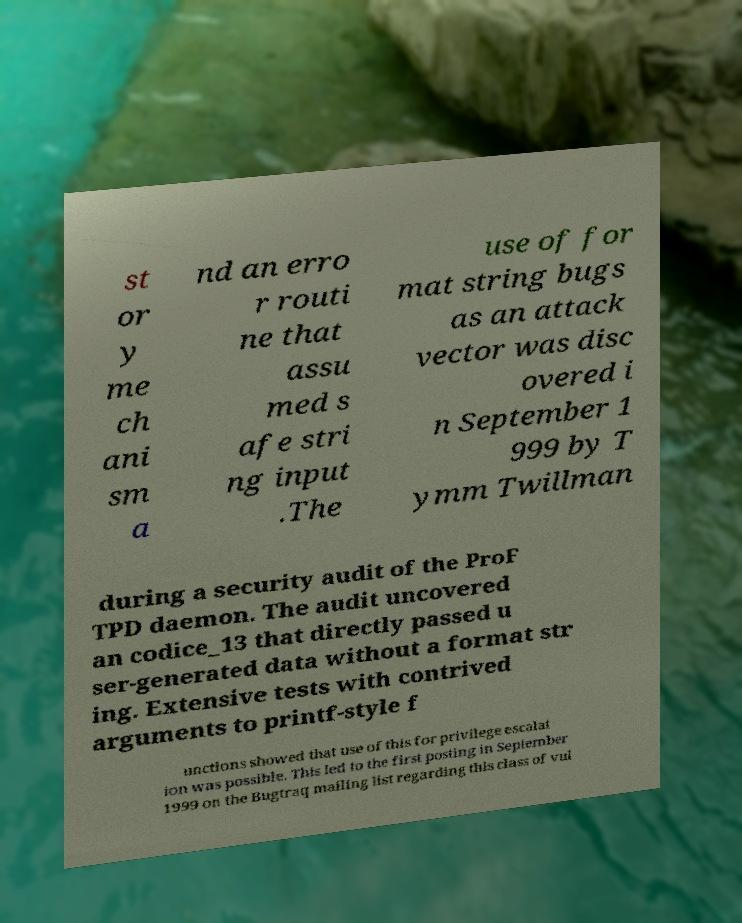Please identify and transcribe the text found in this image. st or y me ch ani sm a nd an erro r routi ne that assu med s afe stri ng input .The use of for mat string bugs as an attack vector was disc overed i n September 1 999 by T ymm Twillman during a security audit of the ProF TPD daemon. The audit uncovered an codice_13 that directly passed u ser-generated data without a format str ing. Extensive tests with contrived arguments to printf-style f unctions showed that use of this for privilege escalat ion was possible. This led to the first posting in September 1999 on the Bugtraq mailing list regarding this class of vul 